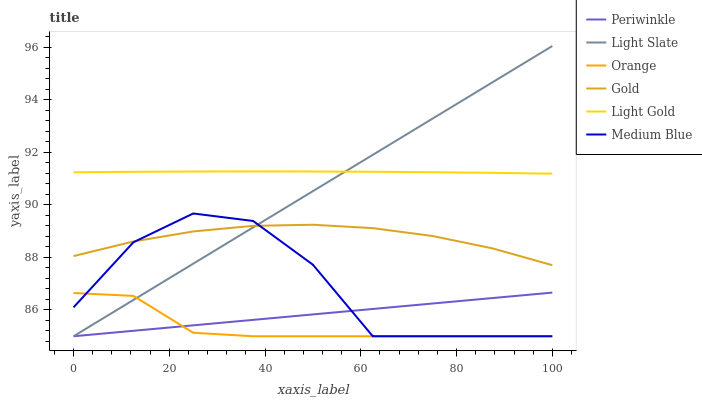Does Orange have the minimum area under the curve?
Answer yes or no. Yes. Does Light Gold have the maximum area under the curve?
Answer yes or no. Yes. Does Light Slate have the minimum area under the curve?
Answer yes or no. No. Does Light Slate have the maximum area under the curve?
Answer yes or no. No. Is Periwinkle the smoothest?
Answer yes or no. Yes. Is Medium Blue the roughest?
Answer yes or no. Yes. Is Light Slate the smoothest?
Answer yes or no. No. Is Light Slate the roughest?
Answer yes or no. No. Does Light Slate have the lowest value?
Answer yes or no. Yes. Does Light Gold have the lowest value?
Answer yes or no. No. Does Light Slate have the highest value?
Answer yes or no. Yes. Does Medium Blue have the highest value?
Answer yes or no. No. Is Medium Blue less than Light Gold?
Answer yes or no. Yes. Is Gold greater than Orange?
Answer yes or no. Yes. Does Orange intersect Periwinkle?
Answer yes or no. Yes. Is Orange less than Periwinkle?
Answer yes or no. No. Is Orange greater than Periwinkle?
Answer yes or no. No. Does Medium Blue intersect Light Gold?
Answer yes or no. No. 